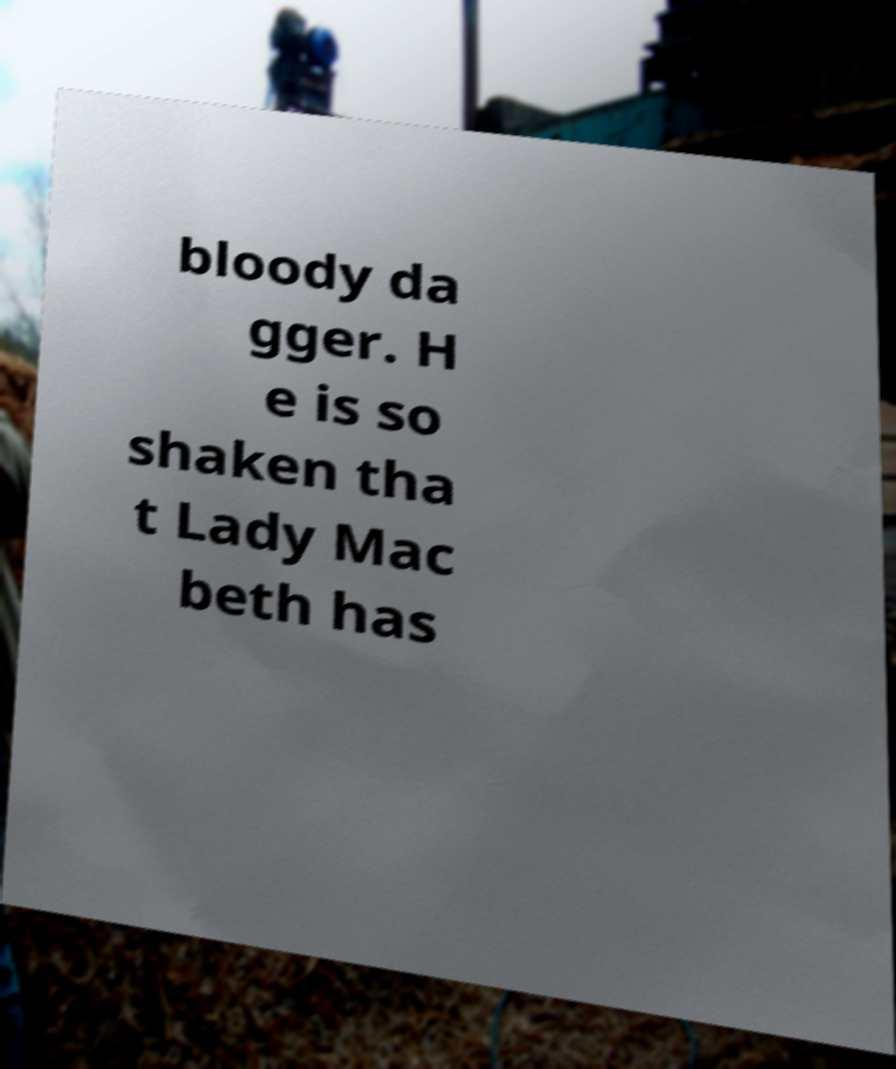What messages or text are displayed in this image? I need them in a readable, typed format. bloody da gger. H e is so shaken tha t Lady Mac beth has 